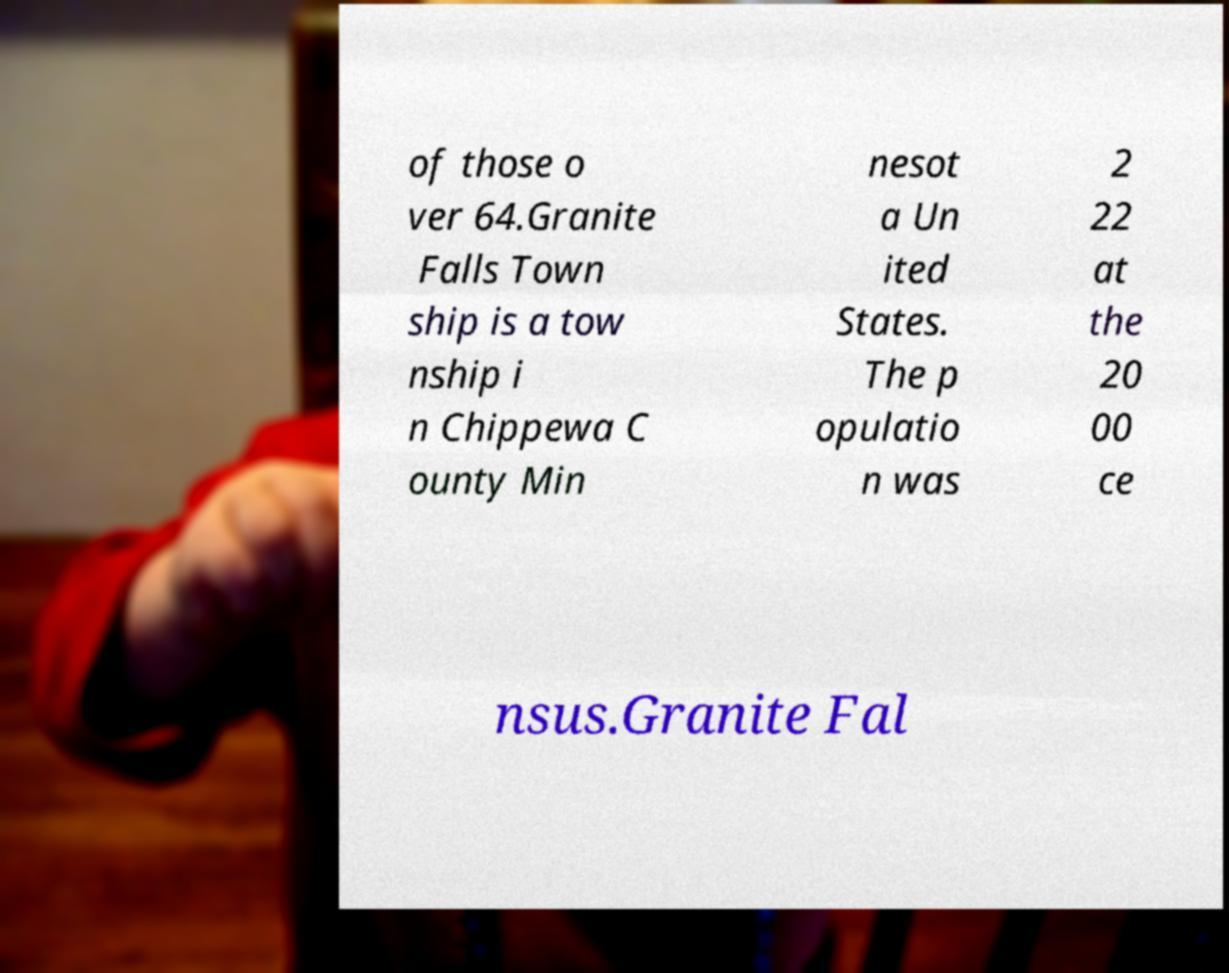Please identify and transcribe the text found in this image. of those o ver 64.Granite Falls Town ship is a tow nship i n Chippewa C ounty Min nesot a Un ited States. The p opulatio n was 2 22 at the 20 00 ce nsus.Granite Fal 